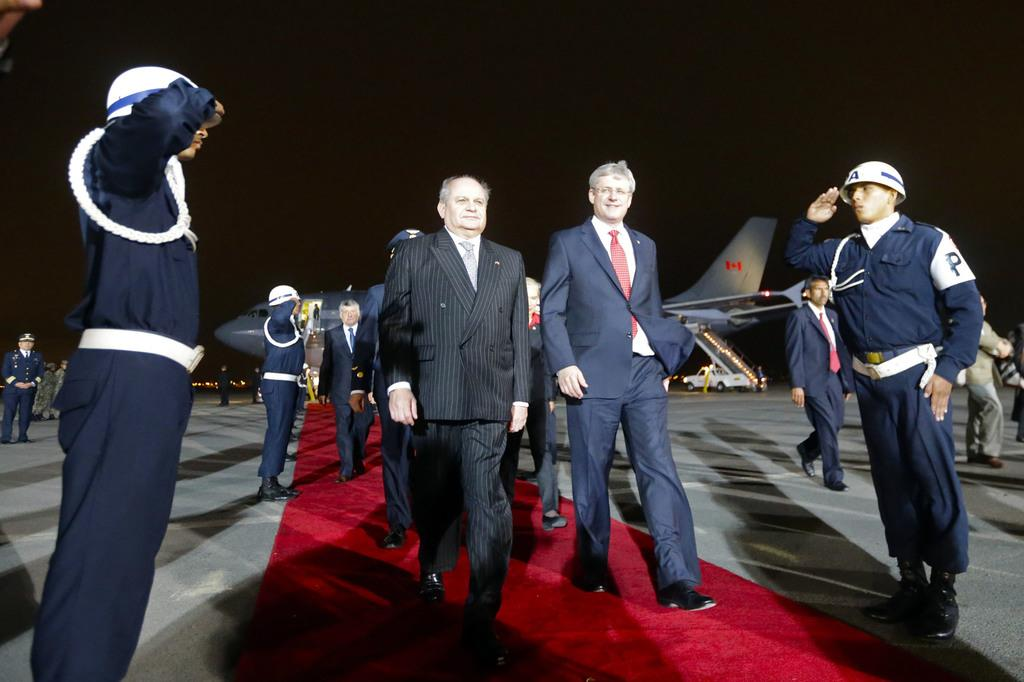Who are the people in the image? There are ministers in the image. What are the ministers doing in the image? The ministers are walking on a red carpet. How are the people around the ministers reacting? There are people saluting the ministers on either side of the red carpet. What can be seen in the background of the image? There is an airplane visible in the background of the image. What type of balance is the lawyer performing in the image? There is no lawyer or balance present in the image. What offer is being made by the ministers in the image? The image does not depict any offers being made by the ministers. 